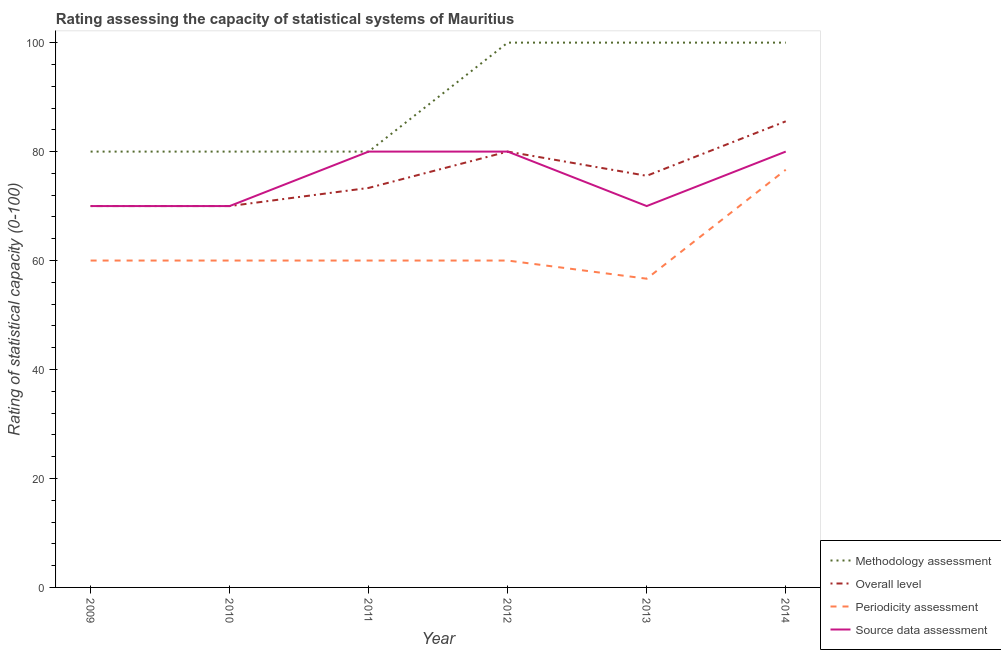What is the overall level rating in 2011?
Provide a succinct answer. 73.33. Across all years, what is the maximum methodology assessment rating?
Your answer should be compact. 100. Across all years, what is the minimum methodology assessment rating?
Make the answer very short. 80. In which year was the overall level rating maximum?
Your answer should be compact. 2014. In which year was the overall level rating minimum?
Provide a short and direct response. 2009. What is the total overall level rating in the graph?
Keep it short and to the point. 454.44. What is the difference between the overall level rating in 2011 and that in 2014?
Your answer should be compact. -12.22. What is the difference between the overall level rating in 2009 and the periodicity assessment rating in 2010?
Offer a terse response. 10. What is the average overall level rating per year?
Offer a terse response. 75.74. In the year 2010, what is the difference between the periodicity assessment rating and source data assessment rating?
Make the answer very short. -10. What is the ratio of the methodology assessment rating in 2009 to that in 2013?
Offer a very short reply. 0.8. Is the methodology assessment rating in 2013 less than that in 2014?
Your response must be concise. No. What is the difference between the highest and the second highest overall level rating?
Provide a short and direct response. 5.56. What is the difference between the highest and the lowest overall level rating?
Make the answer very short. 15.56. In how many years, is the periodicity assessment rating greater than the average periodicity assessment rating taken over all years?
Your answer should be very brief. 1. Is it the case that in every year, the sum of the periodicity assessment rating and overall level rating is greater than the sum of methodology assessment rating and source data assessment rating?
Your response must be concise. No. Is it the case that in every year, the sum of the methodology assessment rating and overall level rating is greater than the periodicity assessment rating?
Make the answer very short. Yes. Is the source data assessment rating strictly greater than the periodicity assessment rating over the years?
Make the answer very short. Yes. Is the periodicity assessment rating strictly less than the source data assessment rating over the years?
Make the answer very short. Yes. How many years are there in the graph?
Offer a very short reply. 6. What is the difference between two consecutive major ticks on the Y-axis?
Provide a succinct answer. 20. Are the values on the major ticks of Y-axis written in scientific E-notation?
Your answer should be very brief. No. Does the graph contain grids?
Your answer should be very brief. No. How are the legend labels stacked?
Give a very brief answer. Vertical. What is the title of the graph?
Provide a short and direct response. Rating assessing the capacity of statistical systems of Mauritius. What is the label or title of the Y-axis?
Give a very brief answer. Rating of statistical capacity (0-100). What is the Rating of statistical capacity (0-100) in Methodology assessment in 2010?
Your answer should be very brief. 80. What is the Rating of statistical capacity (0-100) in Source data assessment in 2010?
Offer a terse response. 70. What is the Rating of statistical capacity (0-100) in Methodology assessment in 2011?
Keep it short and to the point. 80. What is the Rating of statistical capacity (0-100) of Overall level in 2011?
Provide a succinct answer. 73.33. What is the Rating of statistical capacity (0-100) in Periodicity assessment in 2011?
Offer a very short reply. 60. What is the Rating of statistical capacity (0-100) in Source data assessment in 2011?
Your response must be concise. 80. What is the Rating of statistical capacity (0-100) of Methodology assessment in 2012?
Your answer should be compact. 100. What is the Rating of statistical capacity (0-100) in Overall level in 2012?
Your response must be concise. 80. What is the Rating of statistical capacity (0-100) in Periodicity assessment in 2012?
Make the answer very short. 60. What is the Rating of statistical capacity (0-100) in Source data assessment in 2012?
Offer a very short reply. 80. What is the Rating of statistical capacity (0-100) of Overall level in 2013?
Offer a very short reply. 75.56. What is the Rating of statistical capacity (0-100) in Periodicity assessment in 2013?
Your response must be concise. 56.67. What is the Rating of statistical capacity (0-100) in Source data assessment in 2013?
Your response must be concise. 70. What is the Rating of statistical capacity (0-100) of Methodology assessment in 2014?
Keep it short and to the point. 100. What is the Rating of statistical capacity (0-100) in Overall level in 2014?
Provide a short and direct response. 85.56. What is the Rating of statistical capacity (0-100) of Periodicity assessment in 2014?
Keep it short and to the point. 76.67. Across all years, what is the maximum Rating of statistical capacity (0-100) in Methodology assessment?
Provide a succinct answer. 100. Across all years, what is the maximum Rating of statistical capacity (0-100) in Overall level?
Provide a short and direct response. 85.56. Across all years, what is the maximum Rating of statistical capacity (0-100) of Periodicity assessment?
Provide a succinct answer. 76.67. Across all years, what is the minimum Rating of statistical capacity (0-100) in Overall level?
Make the answer very short. 70. Across all years, what is the minimum Rating of statistical capacity (0-100) in Periodicity assessment?
Your answer should be very brief. 56.67. Across all years, what is the minimum Rating of statistical capacity (0-100) in Source data assessment?
Provide a succinct answer. 70. What is the total Rating of statistical capacity (0-100) of Methodology assessment in the graph?
Provide a succinct answer. 540. What is the total Rating of statistical capacity (0-100) in Overall level in the graph?
Ensure brevity in your answer.  454.44. What is the total Rating of statistical capacity (0-100) in Periodicity assessment in the graph?
Give a very brief answer. 373.33. What is the total Rating of statistical capacity (0-100) in Source data assessment in the graph?
Provide a succinct answer. 450. What is the difference between the Rating of statistical capacity (0-100) in Overall level in 2009 and that in 2010?
Keep it short and to the point. 0. What is the difference between the Rating of statistical capacity (0-100) of Methodology assessment in 2009 and that in 2011?
Keep it short and to the point. 0. What is the difference between the Rating of statistical capacity (0-100) of Source data assessment in 2009 and that in 2011?
Give a very brief answer. -10. What is the difference between the Rating of statistical capacity (0-100) of Methodology assessment in 2009 and that in 2012?
Provide a short and direct response. -20. What is the difference between the Rating of statistical capacity (0-100) in Source data assessment in 2009 and that in 2012?
Make the answer very short. -10. What is the difference between the Rating of statistical capacity (0-100) of Overall level in 2009 and that in 2013?
Make the answer very short. -5.56. What is the difference between the Rating of statistical capacity (0-100) in Periodicity assessment in 2009 and that in 2013?
Make the answer very short. 3.33. What is the difference between the Rating of statistical capacity (0-100) in Source data assessment in 2009 and that in 2013?
Keep it short and to the point. 0. What is the difference between the Rating of statistical capacity (0-100) of Overall level in 2009 and that in 2014?
Ensure brevity in your answer.  -15.56. What is the difference between the Rating of statistical capacity (0-100) in Periodicity assessment in 2009 and that in 2014?
Your answer should be compact. -16.67. What is the difference between the Rating of statistical capacity (0-100) of Source data assessment in 2009 and that in 2014?
Offer a very short reply. -10. What is the difference between the Rating of statistical capacity (0-100) in Overall level in 2010 and that in 2011?
Your answer should be compact. -3.33. What is the difference between the Rating of statistical capacity (0-100) in Source data assessment in 2010 and that in 2011?
Give a very brief answer. -10. What is the difference between the Rating of statistical capacity (0-100) of Methodology assessment in 2010 and that in 2012?
Keep it short and to the point. -20. What is the difference between the Rating of statistical capacity (0-100) in Overall level in 2010 and that in 2012?
Offer a very short reply. -10. What is the difference between the Rating of statistical capacity (0-100) of Source data assessment in 2010 and that in 2012?
Your answer should be compact. -10. What is the difference between the Rating of statistical capacity (0-100) of Overall level in 2010 and that in 2013?
Your answer should be very brief. -5.56. What is the difference between the Rating of statistical capacity (0-100) in Overall level in 2010 and that in 2014?
Your answer should be compact. -15.56. What is the difference between the Rating of statistical capacity (0-100) of Periodicity assessment in 2010 and that in 2014?
Ensure brevity in your answer.  -16.67. What is the difference between the Rating of statistical capacity (0-100) in Overall level in 2011 and that in 2012?
Offer a very short reply. -6.67. What is the difference between the Rating of statistical capacity (0-100) in Periodicity assessment in 2011 and that in 2012?
Offer a terse response. 0. What is the difference between the Rating of statistical capacity (0-100) in Source data assessment in 2011 and that in 2012?
Keep it short and to the point. 0. What is the difference between the Rating of statistical capacity (0-100) in Overall level in 2011 and that in 2013?
Offer a terse response. -2.22. What is the difference between the Rating of statistical capacity (0-100) of Periodicity assessment in 2011 and that in 2013?
Your response must be concise. 3.33. What is the difference between the Rating of statistical capacity (0-100) of Source data assessment in 2011 and that in 2013?
Provide a short and direct response. 10. What is the difference between the Rating of statistical capacity (0-100) in Methodology assessment in 2011 and that in 2014?
Your answer should be compact. -20. What is the difference between the Rating of statistical capacity (0-100) in Overall level in 2011 and that in 2014?
Ensure brevity in your answer.  -12.22. What is the difference between the Rating of statistical capacity (0-100) in Periodicity assessment in 2011 and that in 2014?
Your response must be concise. -16.67. What is the difference between the Rating of statistical capacity (0-100) of Methodology assessment in 2012 and that in 2013?
Provide a succinct answer. 0. What is the difference between the Rating of statistical capacity (0-100) in Overall level in 2012 and that in 2013?
Offer a terse response. 4.44. What is the difference between the Rating of statistical capacity (0-100) in Periodicity assessment in 2012 and that in 2013?
Offer a very short reply. 3.33. What is the difference between the Rating of statistical capacity (0-100) in Methodology assessment in 2012 and that in 2014?
Give a very brief answer. 0. What is the difference between the Rating of statistical capacity (0-100) of Overall level in 2012 and that in 2014?
Make the answer very short. -5.56. What is the difference between the Rating of statistical capacity (0-100) of Periodicity assessment in 2012 and that in 2014?
Your response must be concise. -16.67. What is the difference between the Rating of statistical capacity (0-100) in Methodology assessment in 2013 and that in 2014?
Offer a very short reply. 0. What is the difference between the Rating of statistical capacity (0-100) of Source data assessment in 2013 and that in 2014?
Give a very brief answer. -10. What is the difference between the Rating of statistical capacity (0-100) in Methodology assessment in 2009 and the Rating of statistical capacity (0-100) in Periodicity assessment in 2010?
Offer a terse response. 20. What is the difference between the Rating of statistical capacity (0-100) of Methodology assessment in 2009 and the Rating of statistical capacity (0-100) of Source data assessment in 2010?
Your response must be concise. 10. What is the difference between the Rating of statistical capacity (0-100) of Overall level in 2009 and the Rating of statistical capacity (0-100) of Periodicity assessment in 2010?
Your answer should be very brief. 10. What is the difference between the Rating of statistical capacity (0-100) of Periodicity assessment in 2009 and the Rating of statistical capacity (0-100) of Source data assessment in 2010?
Your response must be concise. -10. What is the difference between the Rating of statistical capacity (0-100) of Methodology assessment in 2009 and the Rating of statistical capacity (0-100) of Source data assessment in 2011?
Offer a very short reply. 0. What is the difference between the Rating of statistical capacity (0-100) of Overall level in 2009 and the Rating of statistical capacity (0-100) of Source data assessment in 2011?
Keep it short and to the point. -10. What is the difference between the Rating of statistical capacity (0-100) in Periodicity assessment in 2009 and the Rating of statistical capacity (0-100) in Source data assessment in 2011?
Offer a terse response. -20. What is the difference between the Rating of statistical capacity (0-100) of Overall level in 2009 and the Rating of statistical capacity (0-100) of Source data assessment in 2012?
Provide a short and direct response. -10. What is the difference between the Rating of statistical capacity (0-100) in Methodology assessment in 2009 and the Rating of statistical capacity (0-100) in Overall level in 2013?
Keep it short and to the point. 4.44. What is the difference between the Rating of statistical capacity (0-100) in Methodology assessment in 2009 and the Rating of statistical capacity (0-100) in Periodicity assessment in 2013?
Give a very brief answer. 23.33. What is the difference between the Rating of statistical capacity (0-100) in Methodology assessment in 2009 and the Rating of statistical capacity (0-100) in Source data assessment in 2013?
Your answer should be very brief. 10. What is the difference between the Rating of statistical capacity (0-100) of Overall level in 2009 and the Rating of statistical capacity (0-100) of Periodicity assessment in 2013?
Your response must be concise. 13.33. What is the difference between the Rating of statistical capacity (0-100) in Overall level in 2009 and the Rating of statistical capacity (0-100) in Source data assessment in 2013?
Your answer should be very brief. 0. What is the difference between the Rating of statistical capacity (0-100) in Methodology assessment in 2009 and the Rating of statistical capacity (0-100) in Overall level in 2014?
Give a very brief answer. -5.56. What is the difference between the Rating of statistical capacity (0-100) in Methodology assessment in 2009 and the Rating of statistical capacity (0-100) in Source data assessment in 2014?
Provide a succinct answer. 0. What is the difference between the Rating of statistical capacity (0-100) of Overall level in 2009 and the Rating of statistical capacity (0-100) of Periodicity assessment in 2014?
Offer a terse response. -6.67. What is the difference between the Rating of statistical capacity (0-100) of Overall level in 2009 and the Rating of statistical capacity (0-100) of Source data assessment in 2014?
Your answer should be very brief. -10. What is the difference between the Rating of statistical capacity (0-100) of Periodicity assessment in 2009 and the Rating of statistical capacity (0-100) of Source data assessment in 2014?
Offer a very short reply. -20. What is the difference between the Rating of statistical capacity (0-100) of Methodology assessment in 2010 and the Rating of statistical capacity (0-100) of Periodicity assessment in 2011?
Your response must be concise. 20. What is the difference between the Rating of statistical capacity (0-100) in Methodology assessment in 2010 and the Rating of statistical capacity (0-100) in Source data assessment in 2011?
Your answer should be compact. 0. What is the difference between the Rating of statistical capacity (0-100) in Periodicity assessment in 2010 and the Rating of statistical capacity (0-100) in Source data assessment in 2011?
Offer a very short reply. -20. What is the difference between the Rating of statistical capacity (0-100) in Methodology assessment in 2010 and the Rating of statistical capacity (0-100) in Overall level in 2012?
Provide a succinct answer. 0. What is the difference between the Rating of statistical capacity (0-100) of Methodology assessment in 2010 and the Rating of statistical capacity (0-100) of Periodicity assessment in 2012?
Ensure brevity in your answer.  20. What is the difference between the Rating of statistical capacity (0-100) of Periodicity assessment in 2010 and the Rating of statistical capacity (0-100) of Source data assessment in 2012?
Provide a succinct answer. -20. What is the difference between the Rating of statistical capacity (0-100) in Methodology assessment in 2010 and the Rating of statistical capacity (0-100) in Overall level in 2013?
Give a very brief answer. 4.44. What is the difference between the Rating of statistical capacity (0-100) in Methodology assessment in 2010 and the Rating of statistical capacity (0-100) in Periodicity assessment in 2013?
Provide a succinct answer. 23.33. What is the difference between the Rating of statistical capacity (0-100) of Methodology assessment in 2010 and the Rating of statistical capacity (0-100) of Source data assessment in 2013?
Provide a succinct answer. 10. What is the difference between the Rating of statistical capacity (0-100) of Overall level in 2010 and the Rating of statistical capacity (0-100) of Periodicity assessment in 2013?
Provide a short and direct response. 13.33. What is the difference between the Rating of statistical capacity (0-100) of Periodicity assessment in 2010 and the Rating of statistical capacity (0-100) of Source data assessment in 2013?
Give a very brief answer. -10. What is the difference between the Rating of statistical capacity (0-100) in Methodology assessment in 2010 and the Rating of statistical capacity (0-100) in Overall level in 2014?
Make the answer very short. -5.56. What is the difference between the Rating of statistical capacity (0-100) in Overall level in 2010 and the Rating of statistical capacity (0-100) in Periodicity assessment in 2014?
Offer a very short reply. -6.67. What is the difference between the Rating of statistical capacity (0-100) of Methodology assessment in 2011 and the Rating of statistical capacity (0-100) of Periodicity assessment in 2012?
Offer a terse response. 20. What is the difference between the Rating of statistical capacity (0-100) of Overall level in 2011 and the Rating of statistical capacity (0-100) of Periodicity assessment in 2012?
Your answer should be compact. 13.33. What is the difference between the Rating of statistical capacity (0-100) in Overall level in 2011 and the Rating of statistical capacity (0-100) in Source data assessment in 2012?
Your answer should be very brief. -6.67. What is the difference between the Rating of statistical capacity (0-100) of Methodology assessment in 2011 and the Rating of statistical capacity (0-100) of Overall level in 2013?
Your answer should be compact. 4.44. What is the difference between the Rating of statistical capacity (0-100) in Methodology assessment in 2011 and the Rating of statistical capacity (0-100) in Periodicity assessment in 2013?
Your answer should be very brief. 23.33. What is the difference between the Rating of statistical capacity (0-100) in Overall level in 2011 and the Rating of statistical capacity (0-100) in Periodicity assessment in 2013?
Make the answer very short. 16.67. What is the difference between the Rating of statistical capacity (0-100) of Overall level in 2011 and the Rating of statistical capacity (0-100) of Source data assessment in 2013?
Your answer should be very brief. 3.33. What is the difference between the Rating of statistical capacity (0-100) of Methodology assessment in 2011 and the Rating of statistical capacity (0-100) of Overall level in 2014?
Keep it short and to the point. -5.56. What is the difference between the Rating of statistical capacity (0-100) in Methodology assessment in 2011 and the Rating of statistical capacity (0-100) in Periodicity assessment in 2014?
Your response must be concise. 3.33. What is the difference between the Rating of statistical capacity (0-100) of Methodology assessment in 2011 and the Rating of statistical capacity (0-100) of Source data assessment in 2014?
Provide a short and direct response. 0. What is the difference between the Rating of statistical capacity (0-100) in Overall level in 2011 and the Rating of statistical capacity (0-100) in Periodicity assessment in 2014?
Offer a terse response. -3.33. What is the difference between the Rating of statistical capacity (0-100) in Overall level in 2011 and the Rating of statistical capacity (0-100) in Source data assessment in 2014?
Your answer should be compact. -6.67. What is the difference between the Rating of statistical capacity (0-100) of Methodology assessment in 2012 and the Rating of statistical capacity (0-100) of Overall level in 2013?
Your response must be concise. 24.44. What is the difference between the Rating of statistical capacity (0-100) of Methodology assessment in 2012 and the Rating of statistical capacity (0-100) of Periodicity assessment in 2013?
Give a very brief answer. 43.33. What is the difference between the Rating of statistical capacity (0-100) in Methodology assessment in 2012 and the Rating of statistical capacity (0-100) in Source data assessment in 2013?
Your answer should be compact. 30. What is the difference between the Rating of statistical capacity (0-100) in Overall level in 2012 and the Rating of statistical capacity (0-100) in Periodicity assessment in 2013?
Ensure brevity in your answer.  23.33. What is the difference between the Rating of statistical capacity (0-100) of Methodology assessment in 2012 and the Rating of statistical capacity (0-100) of Overall level in 2014?
Provide a short and direct response. 14.44. What is the difference between the Rating of statistical capacity (0-100) in Methodology assessment in 2012 and the Rating of statistical capacity (0-100) in Periodicity assessment in 2014?
Offer a very short reply. 23.33. What is the difference between the Rating of statistical capacity (0-100) in Methodology assessment in 2012 and the Rating of statistical capacity (0-100) in Source data assessment in 2014?
Offer a terse response. 20. What is the difference between the Rating of statistical capacity (0-100) of Periodicity assessment in 2012 and the Rating of statistical capacity (0-100) of Source data assessment in 2014?
Ensure brevity in your answer.  -20. What is the difference between the Rating of statistical capacity (0-100) of Methodology assessment in 2013 and the Rating of statistical capacity (0-100) of Overall level in 2014?
Your answer should be compact. 14.44. What is the difference between the Rating of statistical capacity (0-100) in Methodology assessment in 2013 and the Rating of statistical capacity (0-100) in Periodicity assessment in 2014?
Provide a short and direct response. 23.33. What is the difference between the Rating of statistical capacity (0-100) of Overall level in 2013 and the Rating of statistical capacity (0-100) of Periodicity assessment in 2014?
Provide a succinct answer. -1.11. What is the difference between the Rating of statistical capacity (0-100) of Overall level in 2013 and the Rating of statistical capacity (0-100) of Source data assessment in 2014?
Your answer should be compact. -4.44. What is the difference between the Rating of statistical capacity (0-100) of Periodicity assessment in 2013 and the Rating of statistical capacity (0-100) of Source data assessment in 2014?
Make the answer very short. -23.33. What is the average Rating of statistical capacity (0-100) of Methodology assessment per year?
Your response must be concise. 90. What is the average Rating of statistical capacity (0-100) of Overall level per year?
Your answer should be compact. 75.74. What is the average Rating of statistical capacity (0-100) in Periodicity assessment per year?
Keep it short and to the point. 62.22. What is the average Rating of statistical capacity (0-100) in Source data assessment per year?
Your answer should be compact. 75. In the year 2009, what is the difference between the Rating of statistical capacity (0-100) of Methodology assessment and Rating of statistical capacity (0-100) of Periodicity assessment?
Offer a terse response. 20. In the year 2009, what is the difference between the Rating of statistical capacity (0-100) of Methodology assessment and Rating of statistical capacity (0-100) of Source data assessment?
Provide a short and direct response. 10. In the year 2009, what is the difference between the Rating of statistical capacity (0-100) in Overall level and Rating of statistical capacity (0-100) in Periodicity assessment?
Ensure brevity in your answer.  10. In the year 2009, what is the difference between the Rating of statistical capacity (0-100) of Overall level and Rating of statistical capacity (0-100) of Source data assessment?
Your answer should be compact. 0. In the year 2010, what is the difference between the Rating of statistical capacity (0-100) of Methodology assessment and Rating of statistical capacity (0-100) of Overall level?
Your answer should be very brief. 10. In the year 2010, what is the difference between the Rating of statistical capacity (0-100) in Periodicity assessment and Rating of statistical capacity (0-100) in Source data assessment?
Provide a succinct answer. -10. In the year 2011, what is the difference between the Rating of statistical capacity (0-100) of Methodology assessment and Rating of statistical capacity (0-100) of Overall level?
Your answer should be compact. 6.67. In the year 2011, what is the difference between the Rating of statistical capacity (0-100) in Overall level and Rating of statistical capacity (0-100) in Periodicity assessment?
Your answer should be compact. 13.33. In the year 2011, what is the difference between the Rating of statistical capacity (0-100) in Overall level and Rating of statistical capacity (0-100) in Source data assessment?
Provide a succinct answer. -6.67. In the year 2012, what is the difference between the Rating of statistical capacity (0-100) of Overall level and Rating of statistical capacity (0-100) of Periodicity assessment?
Keep it short and to the point. 20. In the year 2012, what is the difference between the Rating of statistical capacity (0-100) of Periodicity assessment and Rating of statistical capacity (0-100) of Source data assessment?
Keep it short and to the point. -20. In the year 2013, what is the difference between the Rating of statistical capacity (0-100) of Methodology assessment and Rating of statistical capacity (0-100) of Overall level?
Your answer should be compact. 24.44. In the year 2013, what is the difference between the Rating of statistical capacity (0-100) in Methodology assessment and Rating of statistical capacity (0-100) in Periodicity assessment?
Offer a terse response. 43.33. In the year 2013, what is the difference between the Rating of statistical capacity (0-100) in Overall level and Rating of statistical capacity (0-100) in Periodicity assessment?
Ensure brevity in your answer.  18.89. In the year 2013, what is the difference between the Rating of statistical capacity (0-100) in Overall level and Rating of statistical capacity (0-100) in Source data assessment?
Provide a short and direct response. 5.56. In the year 2013, what is the difference between the Rating of statistical capacity (0-100) of Periodicity assessment and Rating of statistical capacity (0-100) of Source data assessment?
Keep it short and to the point. -13.33. In the year 2014, what is the difference between the Rating of statistical capacity (0-100) of Methodology assessment and Rating of statistical capacity (0-100) of Overall level?
Your response must be concise. 14.44. In the year 2014, what is the difference between the Rating of statistical capacity (0-100) of Methodology assessment and Rating of statistical capacity (0-100) of Periodicity assessment?
Give a very brief answer. 23.33. In the year 2014, what is the difference between the Rating of statistical capacity (0-100) in Overall level and Rating of statistical capacity (0-100) in Periodicity assessment?
Keep it short and to the point. 8.89. In the year 2014, what is the difference between the Rating of statistical capacity (0-100) in Overall level and Rating of statistical capacity (0-100) in Source data assessment?
Provide a succinct answer. 5.56. What is the ratio of the Rating of statistical capacity (0-100) of Methodology assessment in 2009 to that in 2010?
Your answer should be very brief. 1. What is the ratio of the Rating of statistical capacity (0-100) of Overall level in 2009 to that in 2010?
Your answer should be compact. 1. What is the ratio of the Rating of statistical capacity (0-100) of Periodicity assessment in 2009 to that in 2010?
Provide a succinct answer. 1. What is the ratio of the Rating of statistical capacity (0-100) in Source data assessment in 2009 to that in 2010?
Give a very brief answer. 1. What is the ratio of the Rating of statistical capacity (0-100) of Methodology assessment in 2009 to that in 2011?
Your response must be concise. 1. What is the ratio of the Rating of statistical capacity (0-100) in Overall level in 2009 to that in 2011?
Give a very brief answer. 0.95. What is the ratio of the Rating of statistical capacity (0-100) of Periodicity assessment in 2009 to that in 2011?
Make the answer very short. 1. What is the ratio of the Rating of statistical capacity (0-100) in Methodology assessment in 2009 to that in 2012?
Your answer should be very brief. 0.8. What is the ratio of the Rating of statistical capacity (0-100) in Methodology assessment in 2009 to that in 2013?
Keep it short and to the point. 0.8. What is the ratio of the Rating of statistical capacity (0-100) in Overall level in 2009 to that in 2013?
Your answer should be compact. 0.93. What is the ratio of the Rating of statistical capacity (0-100) in Periodicity assessment in 2009 to that in 2013?
Your answer should be very brief. 1.06. What is the ratio of the Rating of statistical capacity (0-100) in Source data assessment in 2009 to that in 2013?
Offer a terse response. 1. What is the ratio of the Rating of statistical capacity (0-100) in Methodology assessment in 2009 to that in 2014?
Keep it short and to the point. 0.8. What is the ratio of the Rating of statistical capacity (0-100) in Overall level in 2009 to that in 2014?
Provide a short and direct response. 0.82. What is the ratio of the Rating of statistical capacity (0-100) of Periodicity assessment in 2009 to that in 2014?
Your answer should be very brief. 0.78. What is the ratio of the Rating of statistical capacity (0-100) of Overall level in 2010 to that in 2011?
Make the answer very short. 0.95. What is the ratio of the Rating of statistical capacity (0-100) in Source data assessment in 2010 to that in 2011?
Give a very brief answer. 0.88. What is the ratio of the Rating of statistical capacity (0-100) in Methodology assessment in 2010 to that in 2012?
Give a very brief answer. 0.8. What is the ratio of the Rating of statistical capacity (0-100) in Overall level in 2010 to that in 2012?
Make the answer very short. 0.88. What is the ratio of the Rating of statistical capacity (0-100) of Source data assessment in 2010 to that in 2012?
Your response must be concise. 0.88. What is the ratio of the Rating of statistical capacity (0-100) of Methodology assessment in 2010 to that in 2013?
Provide a short and direct response. 0.8. What is the ratio of the Rating of statistical capacity (0-100) in Overall level in 2010 to that in 2013?
Provide a short and direct response. 0.93. What is the ratio of the Rating of statistical capacity (0-100) in Periodicity assessment in 2010 to that in 2013?
Your answer should be very brief. 1.06. What is the ratio of the Rating of statistical capacity (0-100) in Overall level in 2010 to that in 2014?
Your response must be concise. 0.82. What is the ratio of the Rating of statistical capacity (0-100) of Periodicity assessment in 2010 to that in 2014?
Provide a succinct answer. 0.78. What is the ratio of the Rating of statistical capacity (0-100) in Methodology assessment in 2011 to that in 2012?
Offer a terse response. 0.8. What is the ratio of the Rating of statistical capacity (0-100) of Source data assessment in 2011 to that in 2012?
Offer a very short reply. 1. What is the ratio of the Rating of statistical capacity (0-100) in Overall level in 2011 to that in 2013?
Offer a very short reply. 0.97. What is the ratio of the Rating of statistical capacity (0-100) in Periodicity assessment in 2011 to that in 2013?
Provide a succinct answer. 1.06. What is the ratio of the Rating of statistical capacity (0-100) of Methodology assessment in 2011 to that in 2014?
Provide a succinct answer. 0.8. What is the ratio of the Rating of statistical capacity (0-100) in Overall level in 2011 to that in 2014?
Keep it short and to the point. 0.86. What is the ratio of the Rating of statistical capacity (0-100) in Periodicity assessment in 2011 to that in 2014?
Your answer should be very brief. 0.78. What is the ratio of the Rating of statistical capacity (0-100) in Methodology assessment in 2012 to that in 2013?
Give a very brief answer. 1. What is the ratio of the Rating of statistical capacity (0-100) in Overall level in 2012 to that in 2013?
Keep it short and to the point. 1.06. What is the ratio of the Rating of statistical capacity (0-100) of Periodicity assessment in 2012 to that in 2013?
Your answer should be compact. 1.06. What is the ratio of the Rating of statistical capacity (0-100) in Source data assessment in 2012 to that in 2013?
Your answer should be very brief. 1.14. What is the ratio of the Rating of statistical capacity (0-100) in Methodology assessment in 2012 to that in 2014?
Ensure brevity in your answer.  1. What is the ratio of the Rating of statistical capacity (0-100) in Overall level in 2012 to that in 2014?
Your response must be concise. 0.94. What is the ratio of the Rating of statistical capacity (0-100) in Periodicity assessment in 2012 to that in 2014?
Make the answer very short. 0.78. What is the ratio of the Rating of statistical capacity (0-100) of Source data assessment in 2012 to that in 2014?
Ensure brevity in your answer.  1. What is the ratio of the Rating of statistical capacity (0-100) in Overall level in 2013 to that in 2014?
Your response must be concise. 0.88. What is the ratio of the Rating of statistical capacity (0-100) of Periodicity assessment in 2013 to that in 2014?
Keep it short and to the point. 0.74. What is the difference between the highest and the second highest Rating of statistical capacity (0-100) in Overall level?
Make the answer very short. 5.56. What is the difference between the highest and the second highest Rating of statistical capacity (0-100) of Periodicity assessment?
Give a very brief answer. 16.67. What is the difference between the highest and the second highest Rating of statistical capacity (0-100) in Source data assessment?
Ensure brevity in your answer.  0. What is the difference between the highest and the lowest Rating of statistical capacity (0-100) of Methodology assessment?
Offer a terse response. 20. What is the difference between the highest and the lowest Rating of statistical capacity (0-100) of Overall level?
Offer a terse response. 15.56. What is the difference between the highest and the lowest Rating of statistical capacity (0-100) in Periodicity assessment?
Keep it short and to the point. 20. What is the difference between the highest and the lowest Rating of statistical capacity (0-100) of Source data assessment?
Your answer should be compact. 10. 